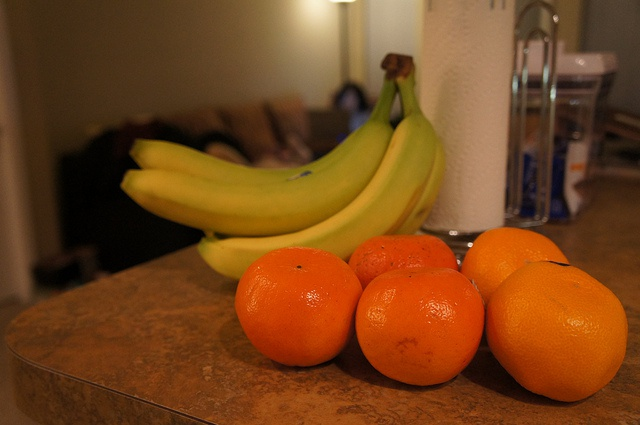Describe the objects in this image and their specific colors. I can see dining table in maroon, red, and brown tones, banana in maroon, olive, and orange tones, orange in maroon and red tones, orange in maroon, red, and brown tones, and orange in maroon, red, and brown tones in this image. 